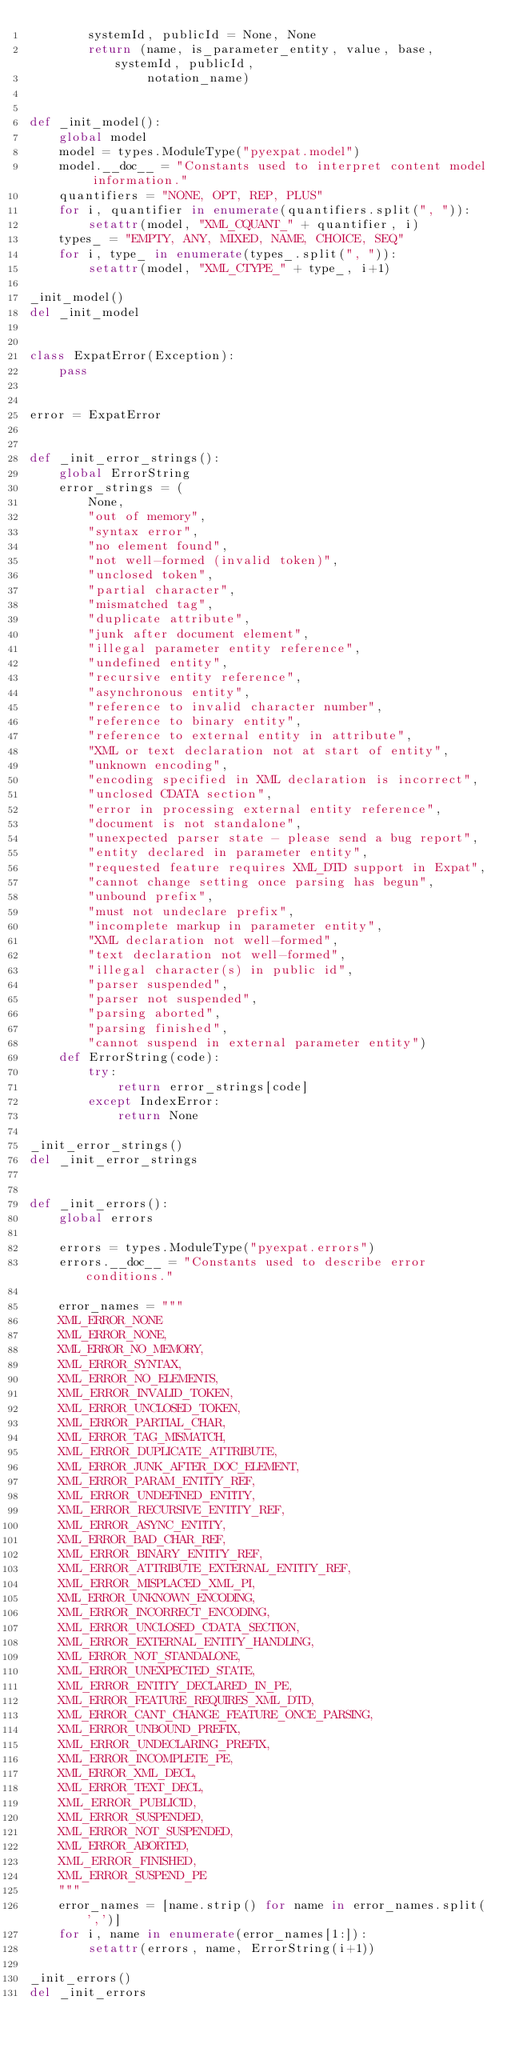Convert code to text. <code><loc_0><loc_0><loc_500><loc_500><_Python_>        systemId, publicId = None, None
        return (name, is_parameter_entity, value, base, systemId, publicId,
                notation_name)


def _init_model():
    global model
    model = types.ModuleType("pyexpat.model")
    model.__doc__ = "Constants used to interpret content model information."
    quantifiers = "NONE, OPT, REP, PLUS"
    for i, quantifier in enumerate(quantifiers.split(", ")):
        setattr(model, "XML_CQUANT_" + quantifier, i)
    types_ = "EMPTY, ANY, MIXED, NAME, CHOICE, SEQ"
    for i, type_ in enumerate(types_.split(", ")):
        setattr(model, "XML_CTYPE_" + type_, i+1)

_init_model()
del _init_model


class ExpatError(Exception):
    pass


error = ExpatError


def _init_error_strings():
    global ErrorString
    error_strings = (
        None,
        "out of memory",
        "syntax error",
        "no element found",
        "not well-formed (invalid token)",
        "unclosed token",
        "partial character",
        "mismatched tag",
        "duplicate attribute",
        "junk after document element",
        "illegal parameter entity reference",
        "undefined entity",
        "recursive entity reference",
        "asynchronous entity",
        "reference to invalid character number",
        "reference to binary entity",
        "reference to external entity in attribute",
        "XML or text declaration not at start of entity",
        "unknown encoding",
        "encoding specified in XML declaration is incorrect",
        "unclosed CDATA section",
        "error in processing external entity reference",
        "document is not standalone",
        "unexpected parser state - please send a bug report",
        "entity declared in parameter entity",
        "requested feature requires XML_DTD support in Expat",
        "cannot change setting once parsing has begun",
        "unbound prefix",
        "must not undeclare prefix",
        "incomplete markup in parameter entity",
        "XML declaration not well-formed",
        "text declaration not well-formed",
        "illegal character(s) in public id",
        "parser suspended",
        "parser not suspended",
        "parsing aborted",
        "parsing finished",
        "cannot suspend in external parameter entity")
    def ErrorString(code):
        try:
            return error_strings[code]
        except IndexError:
            return None

_init_error_strings()
del _init_error_strings


def _init_errors():
    global errors

    errors = types.ModuleType("pyexpat.errors")
    errors.__doc__ = "Constants used to describe error conditions."

    error_names = """
    XML_ERROR_NONE
    XML_ERROR_NONE,
    XML_ERROR_NO_MEMORY,
    XML_ERROR_SYNTAX,
    XML_ERROR_NO_ELEMENTS,
    XML_ERROR_INVALID_TOKEN,
    XML_ERROR_UNCLOSED_TOKEN,
    XML_ERROR_PARTIAL_CHAR,
    XML_ERROR_TAG_MISMATCH,
    XML_ERROR_DUPLICATE_ATTRIBUTE,
    XML_ERROR_JUNK_AFTER_DOC_ELEMENT,
    XML_ERROR_PARAM_ENTITY_REF,
    XML_ERROR_UNDEFINED_ENTITY,
    XML_ERROR_RECURSIVE_ENTITY_REF,
    XML_ERROR_ASYNC_ENTITY,
    XML_ERROR_BAD_CHAR_REF,
    XML_ERROR_BINARY_ENTITY_REF,
    XML_ERROR_ATTRIBUTE_EXTERNAL_ENTITY_REF,
    XML_ERROR_MISPLACED_XML_PI,
    XML_ERROR_UNKNOWN_ENCODING,
    XML_ERROR_INCORRECT_ENCODING,
    XML_ERROR_UNCLOSED_CDATA_SECTION,
    XML_ERROR_EXTERNAL_ENTITY_HANDLING,
    XML_ERROR_NOT_STANDALONE,
    XML_ERROR_UNEXPECTED_STATE,
    XML_ERROR_ENTITY_DECLARED_IN_PE,
    XML_ERROR_FEATURE_REQUIRES_XML_DTD,
    XML_ERROR_CANT_CHANGE_FEATURE_ONCE_PARSING,
    XML_ERROR_UNBOUND_PREFIX,
    XML_ERROR_UNDECLARING_PREFIX,
    XML_ERROR_INCOMPLETE_PE,
    XML_ERROR_XML_DECL,
    XML_ERROR_TEXT_DECL,
    XML_ERROR_PUBLICID,
    XML_ERROR_SUSPENDED,
    XML_ERROR_NOT_SUSPENDED,
    XML_ERROR_ABORTED,
    XML_ERROR_FINISHED,
    XML_ERROR_SUSPEND_PE
    """
    error_names = [name.strip() for name in error_names.split(',')]
    for i, name in enumerate(error_names[1:]):
        setattr(errors, name, ErrorString(i+1))

_init_errors()
del _init_errors
</code> 